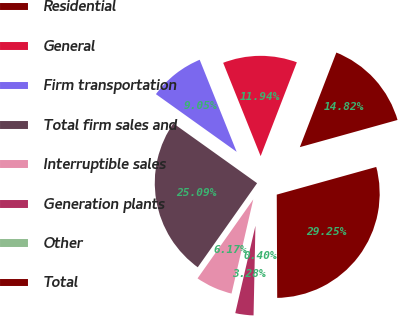Convert chart to OTSL. <chart><loc_0><loc_0><loc_500><loc_500><pie_chart><fcel>Residential<fcel>General<fcel>Firm transportation<fcel>Total firm sales and<fcel>Interruptible sales<fcel>Generation plants<fcel>Other<fcel>Total<nl><fcel>14.82%<fcel>11.94%<fcel>9.05%<fcel>25.09%<fcel>6.17%<fcel>3.28%<fcel>0.4%<fcel>29.25%<nl></chart> 